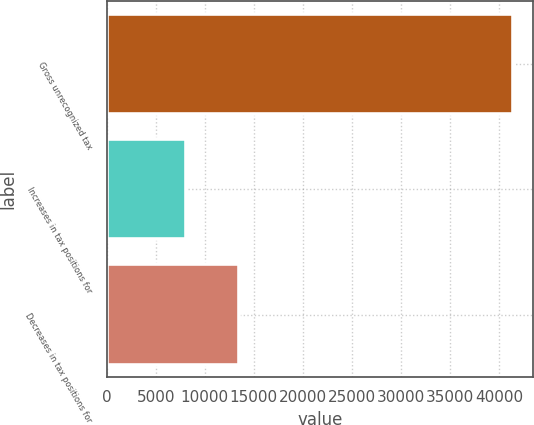<chart> <loc_0><loc_0><loc_500><loc_500><bar_chart><fcel>Gross unrecognized tax<fcel>Increases in tax positions for<fcel>Decreases in tax positions for<nl><fcel>41382<fcel>8040.4<fcel>13482<nl></chart> 